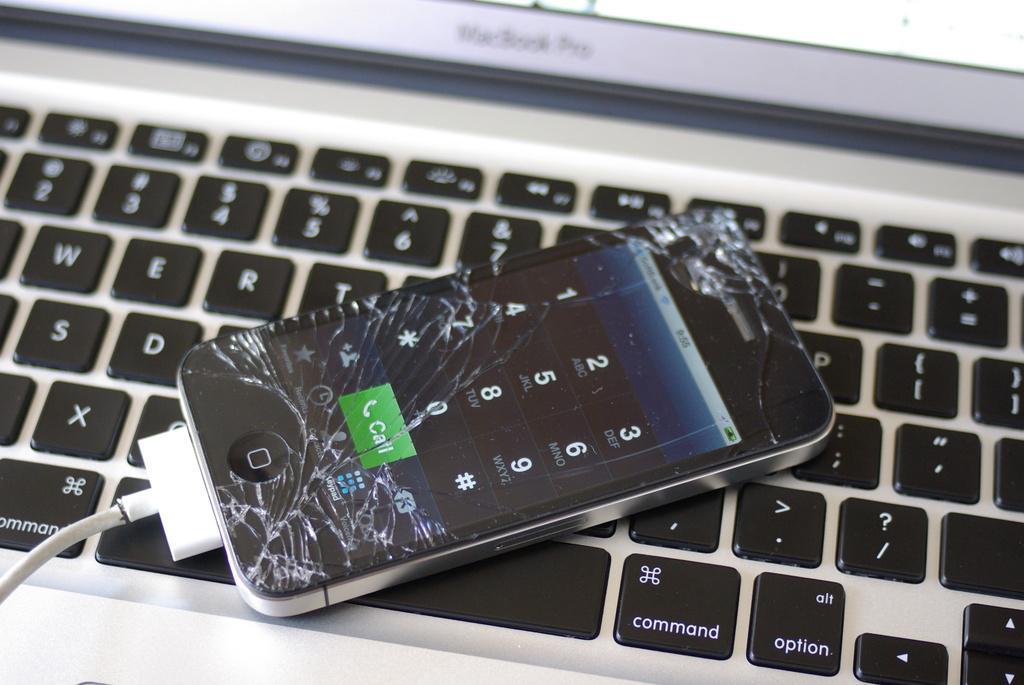Provide a one-sentence caption for the provided image. A shattered cell phone lays on the keyboard of a Mac Book Pro. 